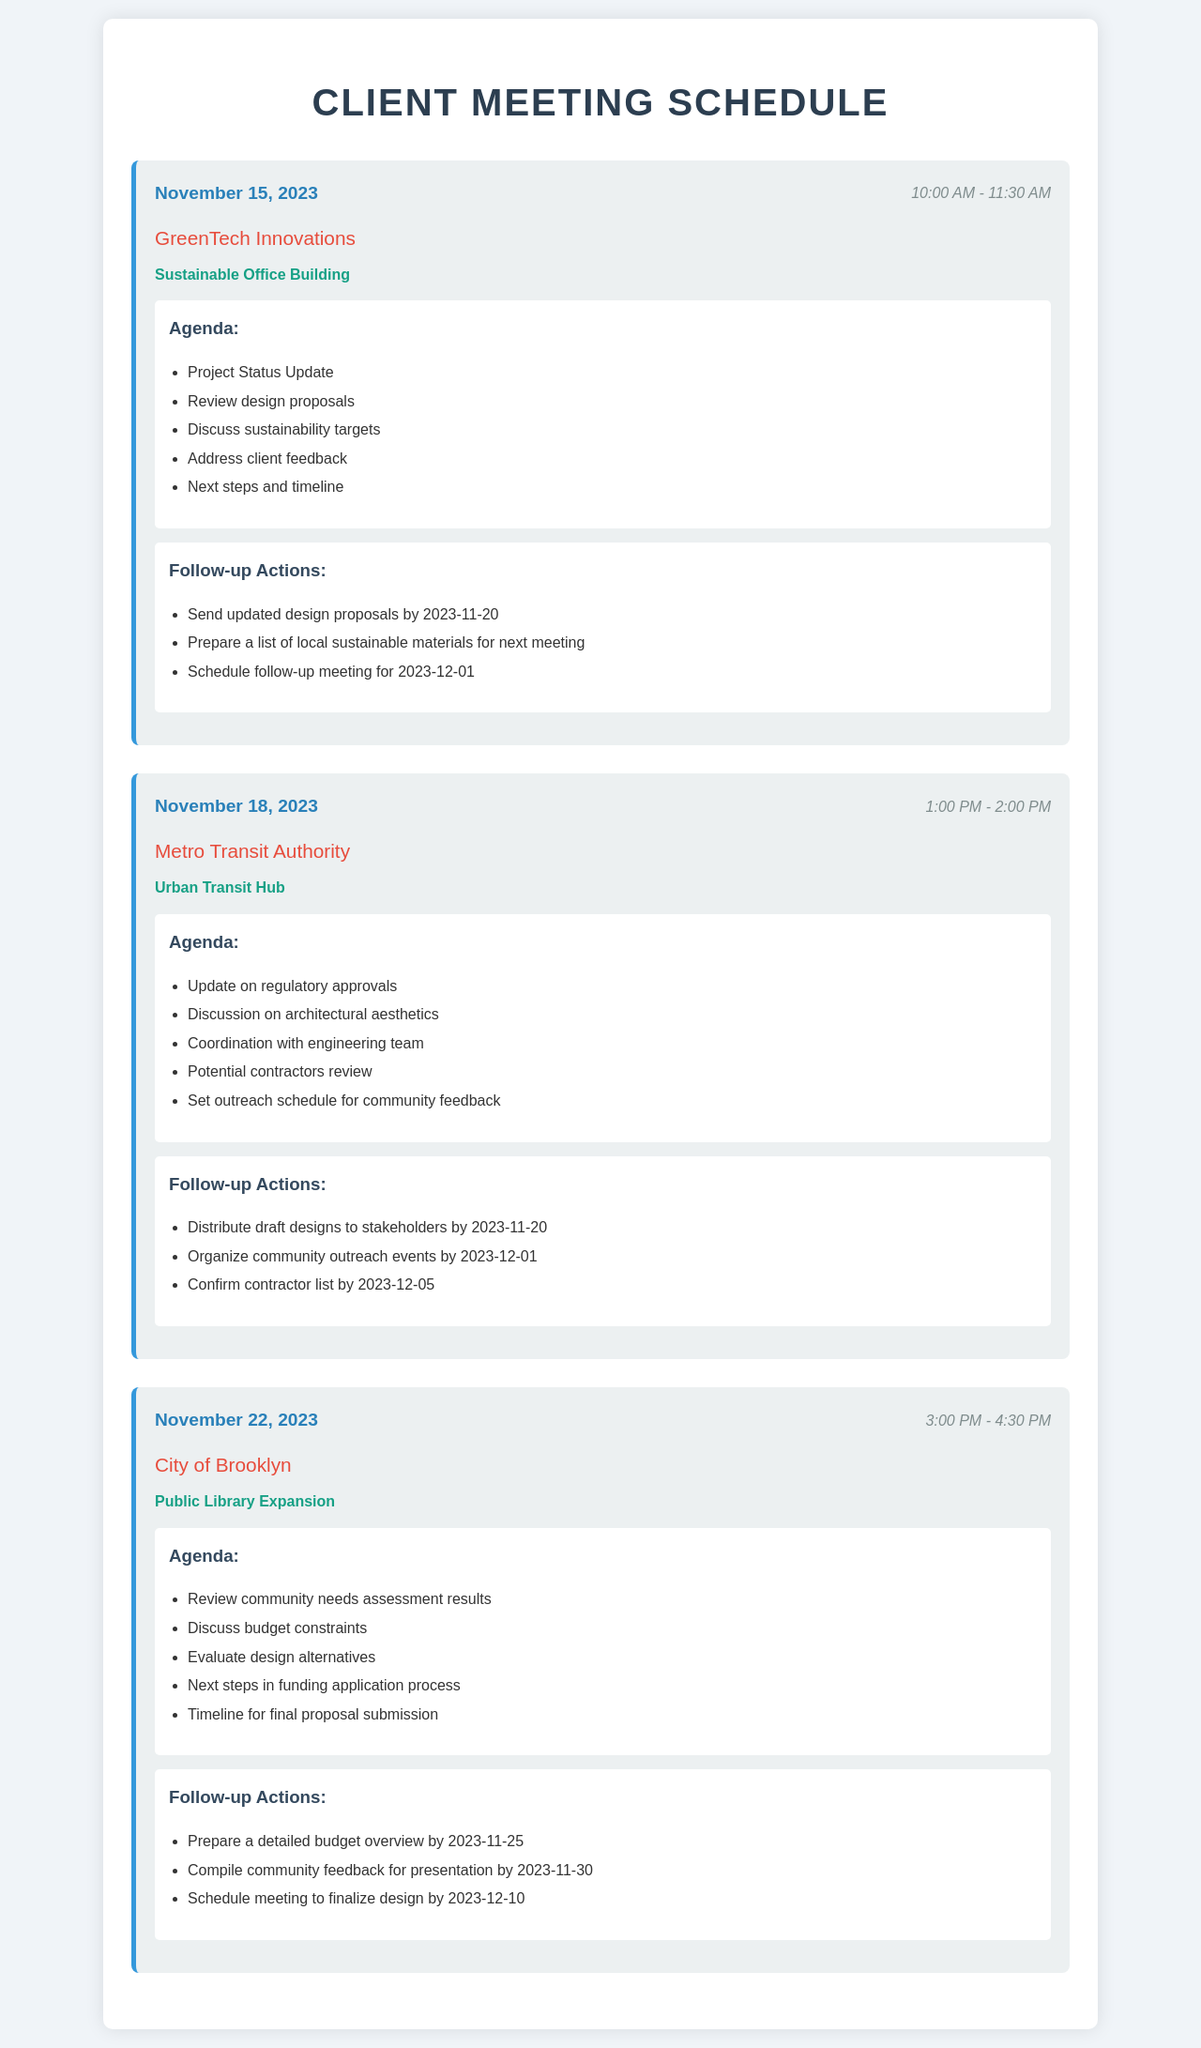What is the date of the meeting with GreenTech Innovations? The date is specified in the meeting section for GreenTech Innovations, which is November 15, 2023.
Answer: November 15, 2023 What project is being discussed in the meeting on November 18, 2023? The project is mentioned in the meeting details, which states Urban Transit Hub for the Metro Transit Authority.
Answer: Urban Transit Hub How long is the meeting scheduled with the City of Brooklyn? The duration of the meeting is indicated as 3:00 PM - 4:30 PM, which is 1.5 hours.
Answer: 1.5 hours Which client has a meeting focusing on sustainability? This is identified in the agenda for the meeting with GreenTech Innovations, which emphasizes sustainability targets.
Answer: GreenTech Innovations What is one follow-up action from the meeting on November 22, 2023? A follow-up action is listed in the document, specifically preparing a detailed budget overview by 2023-11-25.
Answer: Prepare a detailed budget overview by 2023-11-25 What is the focus of the agenda for the meeting on November 18, 2023? The agenda points together indicate discussions on regulatory approvals and architectural aesthetics as the focus topics for the meeting with the Metro Transit Authority.
Answer: Update on regulatory approvals How many agenda items are listed for the Sustainable Office Building meeting? The number of agenda items can be counted from the list provided under the agenda for GreenTech Innovations' meeting, which includes five items.
Answer: Five items When is the follow-up meeting scheduled after the GreenTech Innovations meeting? The date of the follow-up meeting is mentioned under follow-up actions for the GreenTech meeting, scheduled for December 1, 2023.
Answer: December 1, 2023 